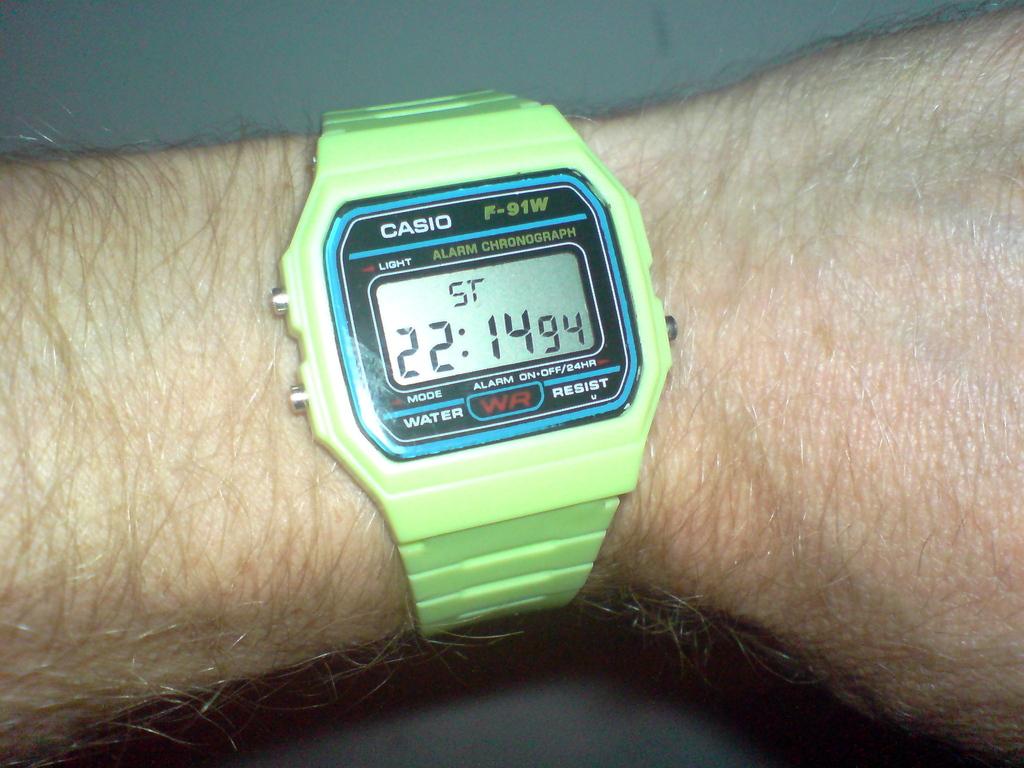What's the make of the watch?
Offer a very short reply. Casio. How many seconds does the watch show?
Provide a short and direct response. 94. 